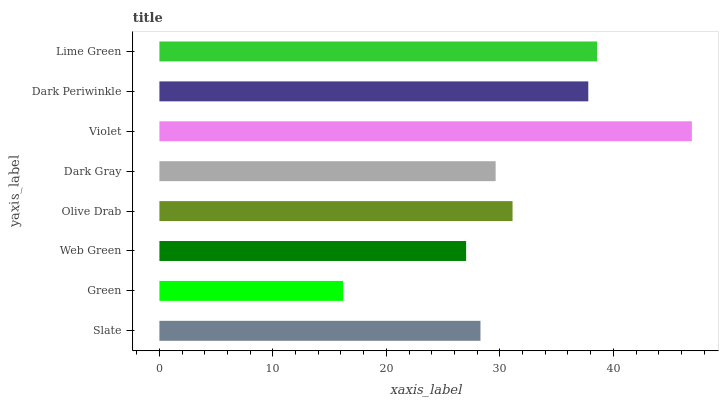Is Green the minimum?
Answer yes or no. Yes. Is Violet the maximum?
Answer yes or no. Yes. Is Web Green the minimum?
Answer yes or no. No. Is Web Green the maximum?
Answer yes or no. No. Is Web Green greater than Green?
Answer yes or no. Yes. Is Green less than Web Green?
Answer yes or no. Yes. Is Green greater than Web Green?
Answer yes or no. No. Is Web Green less than Green?
Answer yes or no. No. Is Olive Drab the high median?
Answer yes or no. Yes. Is Dark Gray the low median?
Answer yes or no. Yes. Is Slate the high median?
Answer yes or no. No. Is Web Green the low median?
Answer yes or no. No. 